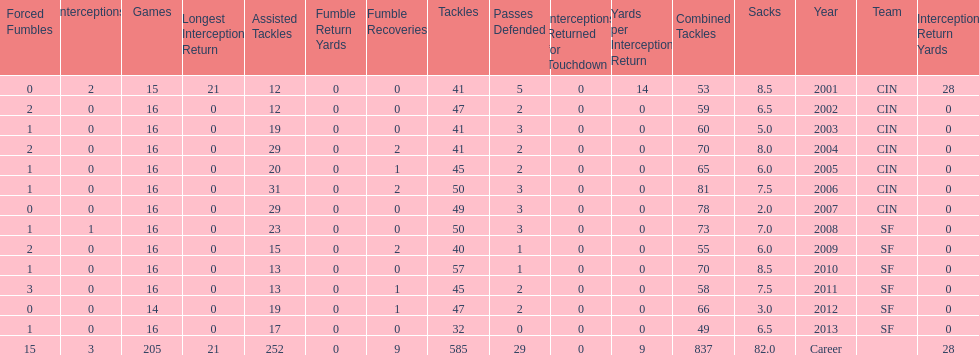How many fumble recoveries did this player have in 2004? 2. 